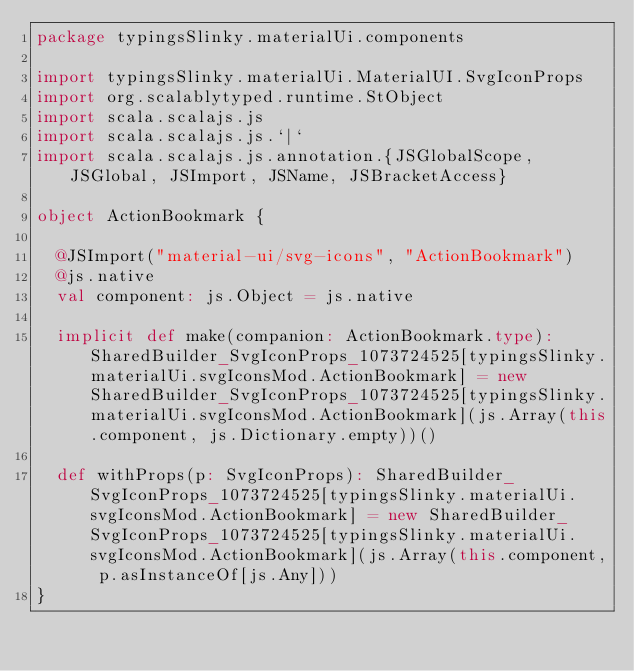<code> <loc_0><loc_0><loc_500><loc_500><_Scala_>package typingsSlinky.materialUi.components

import typingsSlinky.materialUi.MaterialUI.SvgIconProps
import org.scalablytyped.runtime.StObject
import scala.scalajs.js
import scala.scalajs.js.`|`
import scala.scalajs.js.annotation.{JSGlobalScope, JSGlobal, JSImport, JSName, JSBracketAccess}

object ActionBookmark {
  
  @JSImport("material-ui/svg-icons", "ActionBookmark")
  @js.native
  val component: js.Object = js.native
  
  implicit def make(companion: ActionBookmark.type): SharedBuilder_SvgIconProps_1073724525[typingsSlinky.materialUi.svgIconsMod.ActionBookmark] = new SharedBuilder_SvgIconProps_1073724525[typingsSlinky.materialUi.svgIconsMod.ActionBookmark](js.Array(this.component, js.Dictionary.empty))()
  
  def withProps(p: SvgIconProps): SharedBuilder_SvgIconProps_1073724525[typingsSlinky.materialUi.svgIconsMod.ActionBookmark] = new SharedBuilder_SvgIconProps_1073724525[typingsSlinky.materialUi.svgIconsMod.ActionBookmark](js.Array(this.component, p.asInstanceOf[js.Any]))
}
</code> 